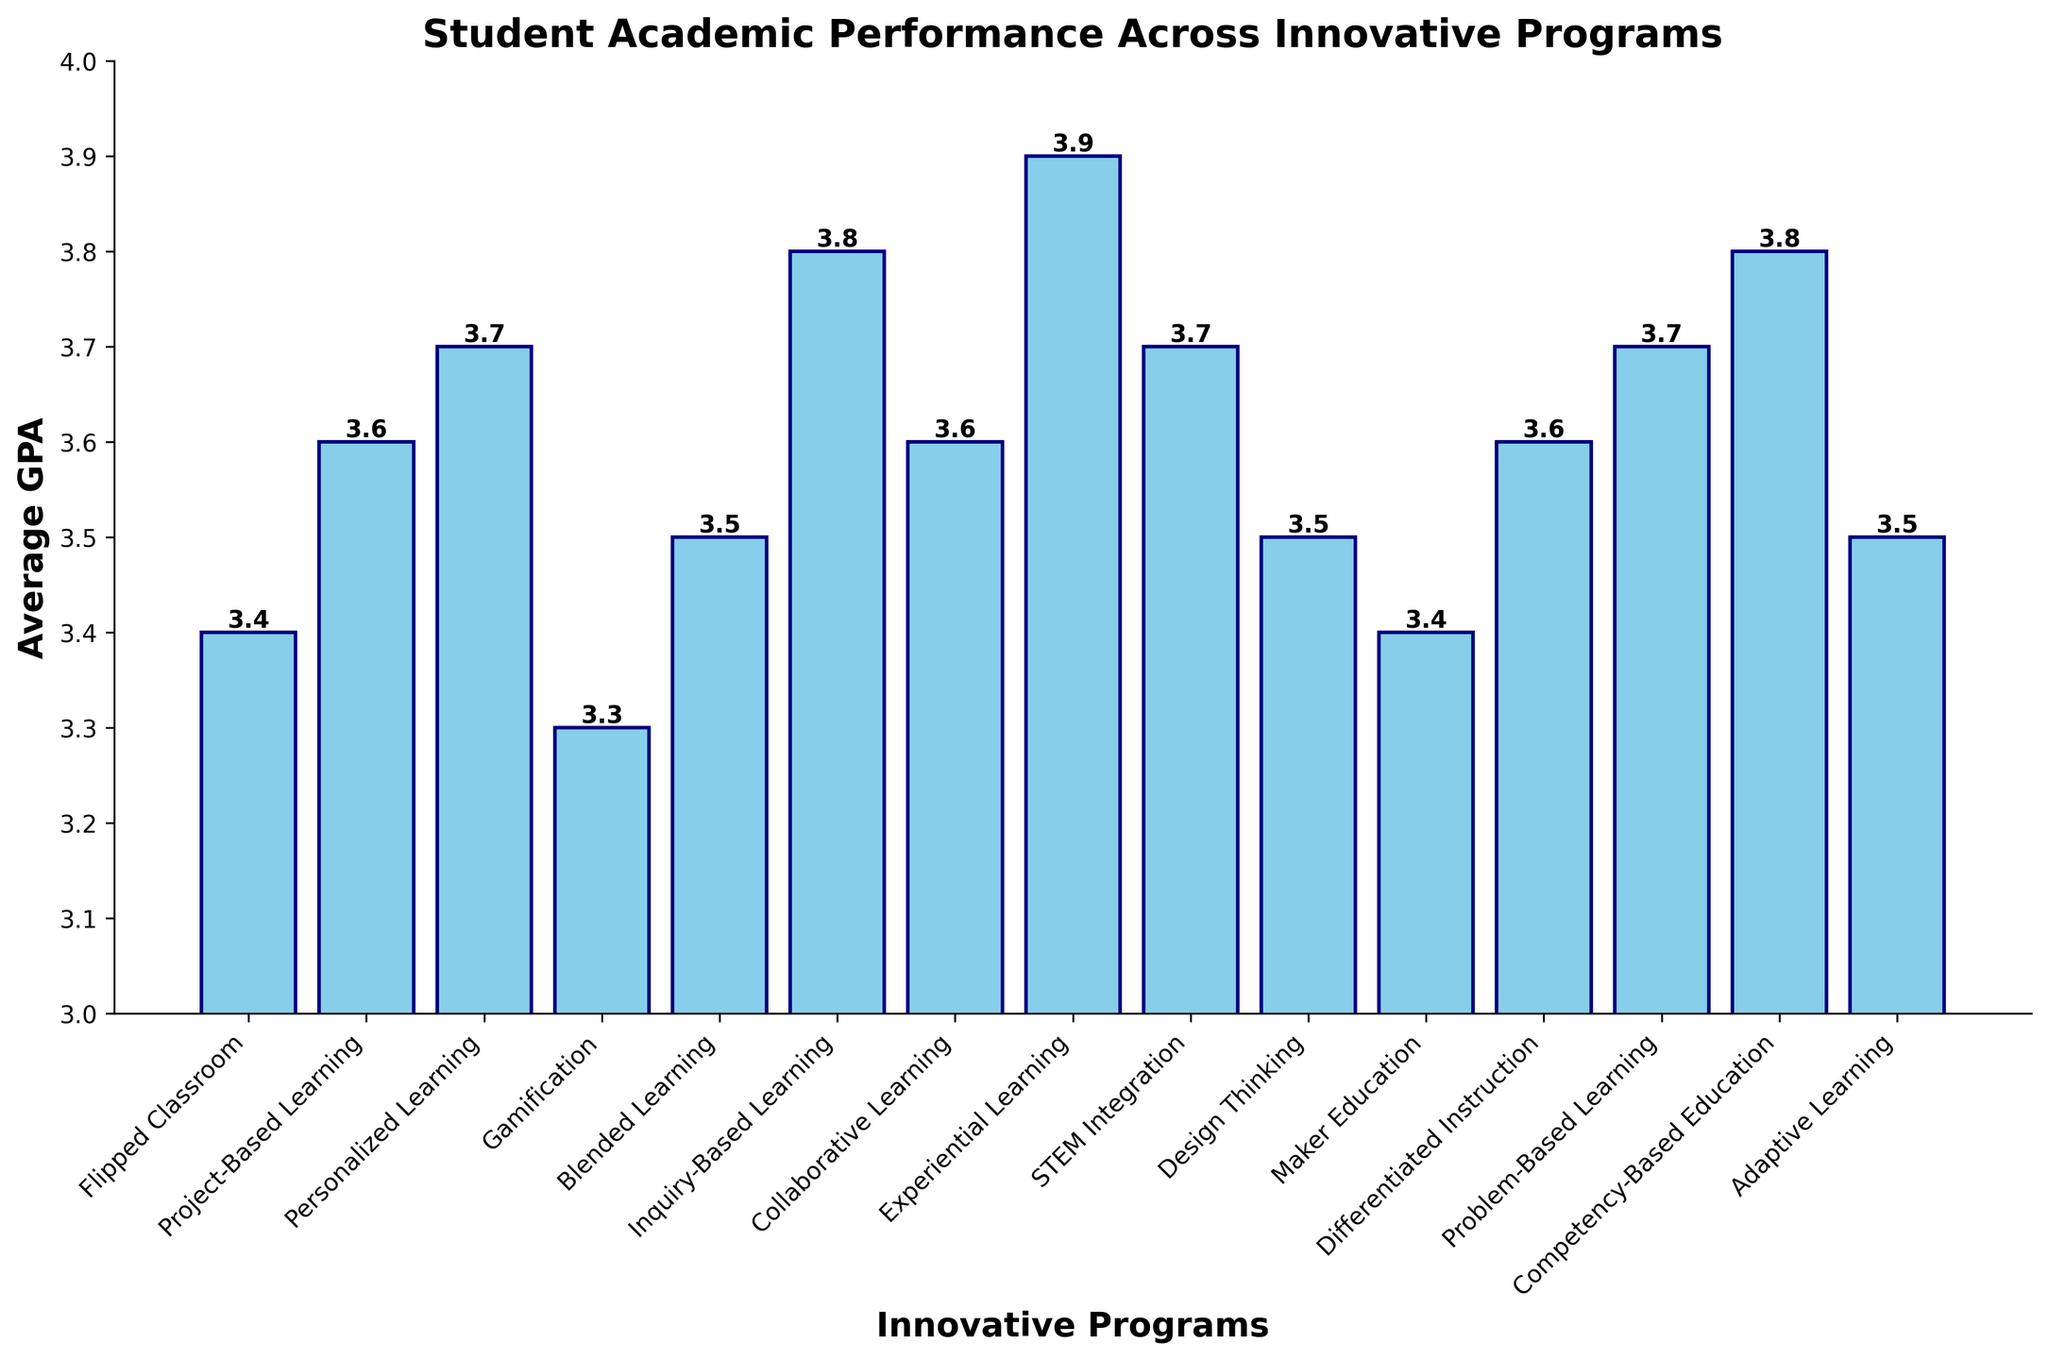Which innovative program has the highest average GPA? To find the program with the highest average GPA, look for the tallest bar in the bar chart. The height of each bar represents the average GPA for that program. The tallest bar corresponds to the "Experiential Learning" program.
Answer: Experiential Learning Which two programs share the same average GPA? Identify the bars that rise to the same level on the y-axis and have their heights marked with the same number. The bars for "Project-Based Learning," "Collaborative Learning," and "Differentiated Instruction" all have an average GPA of 3.6.
Answer: Project-Based Learning and Collaborative Learning and Differentiated Instruction What is the average GPA difference between Gamification and Personalized Learning programs? From the chart, note the GPA for "Gamification" (3.3) and "Personalized Learning" (3.7). Subtract the lower GPA from the higher GPA: 3.7 - 3.3 = 0.4.
Answer: 0.4 Which program has a higher average GPA: Blended Learning or Design Thinking? Compare the height of the bars for "Blended Learning" and "Design Thinking." Blended Learning has a GPA of 3.5, and Design Thinking also has a GPA of 3.5.
Answer: Both are equal How many programs have an average GPA greater than 3.5? Identify the bars taller than the 3.5 mark on the y-axis. The programs "Personalized Learning," "Inquiry-Based Learning," "Collaborative Learning," "Experiential Learning," "STEM Integration," "Problem-Based Learning," and "Competency-Based Education" all have an average GPA greater than 3.5. Count these programs: 7 programs.
Answer: 7 What is the percentage increase in the average GPA from Flipped Classroom to Inquiry-Based Learning? Calculate the initial and final average GPAs (Flipped Classroom: 3.4, Inquiry-Based Learning: 3.8). Use the formula for percentage increase: ((Final - Initial) / Initial) * 100. ((3.8 - 3.4) / 3.4) * 100 = 11.76%.
Answer: 11.76% Which program has the lowest average GPA? Scan the chart for the shortest bar. The bar for "Gamification" is the shortest, with an average GPA of 3.3.
Answer: Gamification What is the combined average GPA of the "STEM Integration" and "Competency-Based Education" programs? Find the average GPAs for both programs (each has a GPA of 3.7 and 3.8 respectively). Sum them: 3.7 + 3.8 = 7.5.
Answer: 7.5 